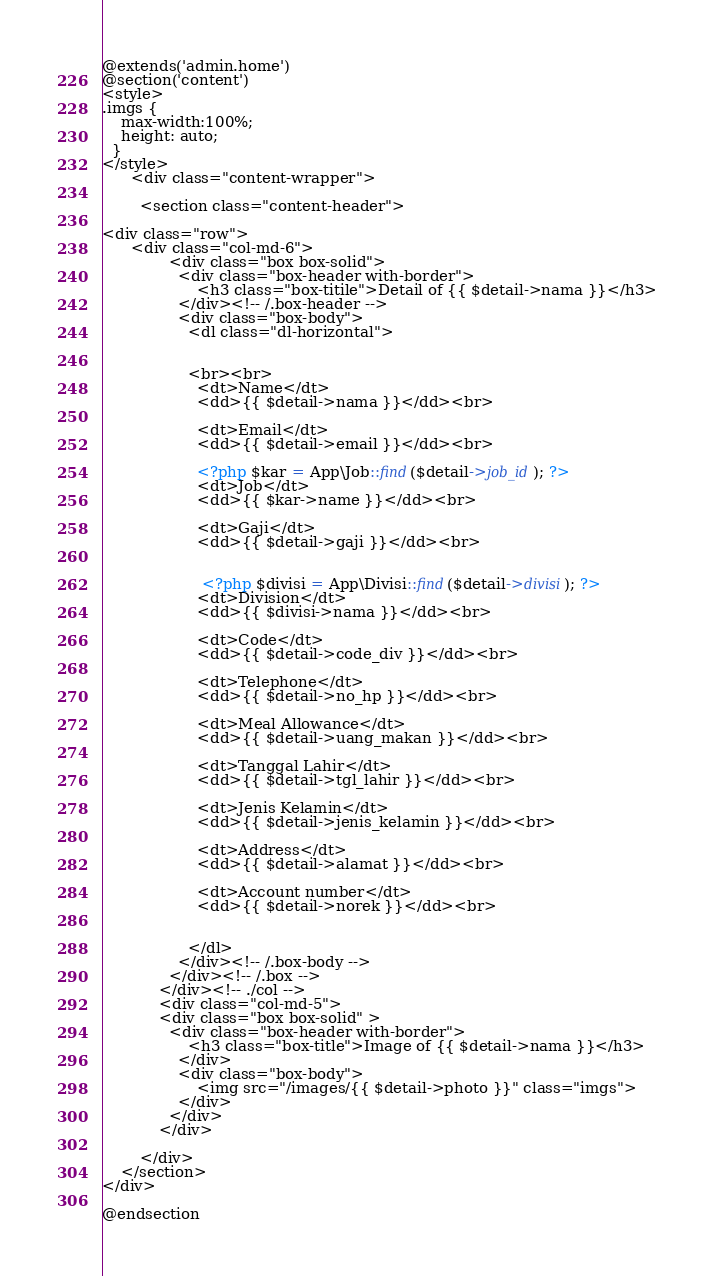<code> <loc_0><loc_0><loc_500><loc_500><_PHP_>@extends('admin.home')
@section('content')
<style>
.imgs {
    max-width:100%;
    height: auto;
  }
</style>
      <div class="content-wrapper">
      
        <section class="content-header">

<div class="row">
      <div class="col-md-6">
              <div class="box box-solid">
                <div class="box-header with-border">
                    <h3 class="box-titile">Detail of {{ $detail->nama }}</h3>
                </div><!-- /.box-header -->
                <div class="box-body">
                  <dl class="dl-horizontal">

                 
                  <br><br>
                    <dt>Name</dt>
                    <dd>{{ $detail->nama }}</dd><br>

                    <dt>Email</dt>
                    <dd>{{ $detail->email }}</dd><br>
                    
                    <?php $kar = App\Job::find($detail->job_id); ?>
                    <dt>Job</dt>
                    <dd>{{ $kar->name }}</dd><br>
                    
                    <dt>Gaji</dt>
                    <dd>{{ $detail->gaji }}</dd><br>
                    

                     <?php $divisi = App\Divisi::find($detail->divisi); ?>
                    <dt>Division</dt>
                    <dd>{{ $divisi->nama }}</dd><br>

                    <dt>Code</dt>
                    <dd>{{ $detail->code_div }}</dd><br>

                    <dt>Telephone</dt>
                    <dd>{{ $detail->no_hp }}</dd><br>
                   
                    <dt>Meal Allowance</dt>
                    <dd>{{ $detail->uang_makan }}</dd><br>
                   
                    <dt>Tanggal Lahir</dt>
                    <dd>{{ $detail->tgl_lahir }}</dd><br>
                   
                    <dt>Jenis Kelamin</dt>
                    <dd>{{ $detail->jenis_kelamin }}</dd><br>
                   
                    <dt>Address</dt>
                    <dd>{{ $detail->alamat }}</dd><br>
                   
                    <dt>Account number</dt>
                    <dd>{{ $detail->norek }}</dd><br>
                   
                   
                  </dl>
                </div><!-- /.box-body -->
              </div><!-- /.box -->
            </div><!-- ./col -->
            <div class="col-md-5">
            <div class="box box-solid" >
              <div class="box-header with-border">
                  <h3 class="box-title">Image of {{ $detail->nama }}</h3>
                </div>
                <div class="box-body">
                    <img src="/images/{{ $detail->photo }}" class="imgs">
                </div>
              </div>
            </div>
            
        </div>
    </section>
</div>

@endsection</code> 